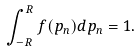<formula> <loc_0><loc_0><loc_500><loc_500>\int _ { - R } ^ { R } f ( p _ { n } ) d p _ { n } = 1 .</formula> 